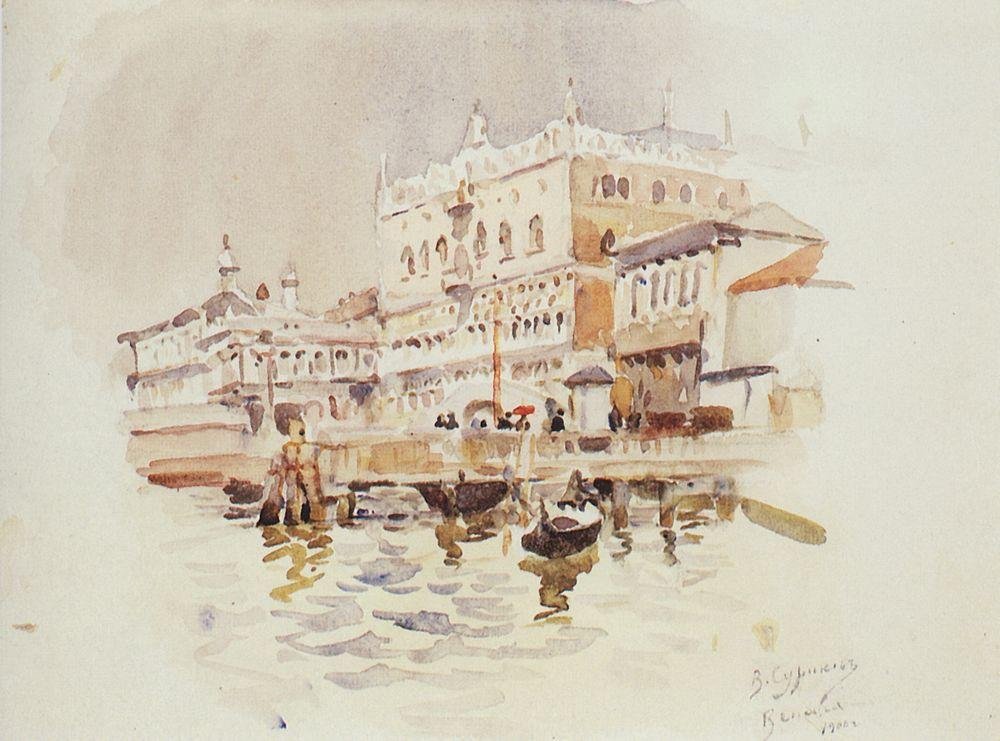Can you describe the mood conveyed by the color palette used in this painting? The artist employs a muted color palette with soft washes of white, beige, and pale blue, creating a serene and somewhat nostalgic mood. This choice of colors, along with the gentle diffusion of light and shadow, evokes a sense of calm and timeless elegance, appropriate for the historic and romantic city of Venice. 